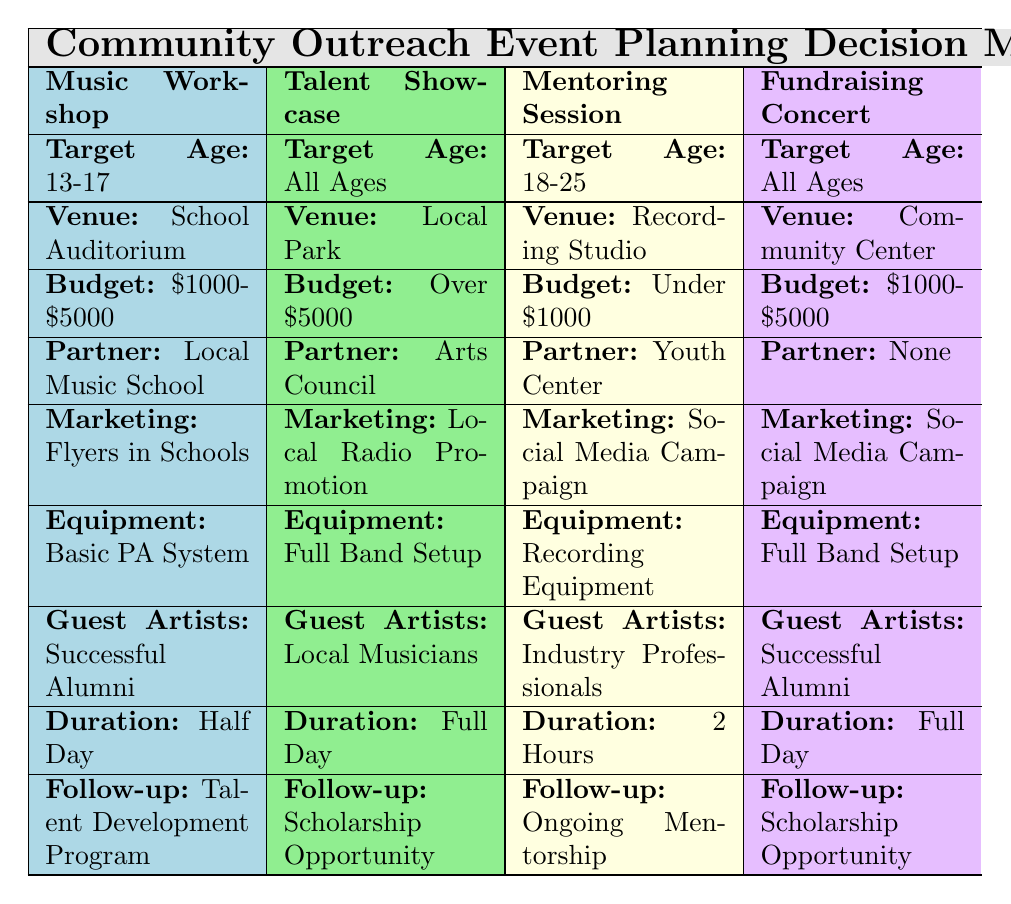What is the target age group for the Talent Showcase event? The table indicates that the target age group for the Talent Showcase event is "All Ages." This is directly referenced in the specific row dedicated to the Talent Showcase.
Answer: All Ages What budget range is associated with the Music Workshop? The Music Workshop has a budget range specified as "$1000-$5000." This information is found in the corresponding row below the Music Workshop column.
Answer: $1000-$5000 True or False: The Fundraising Concert requires a basic PA system. The table shows that the Equipment Needed for the Fundraising Concert is "Full Band Setup," which means it does not require a basic PA system. Thus, the statement is false.
Answer: False What follow-up activity is planned for the Mentoring Session? According to the table, the follow-up activity for the Mentoring Session is "Ongoing Mentorship." This is outlined in the dedicated row for the Mentoring Session.
Answer: Ongoing Mentorship Which event has the longest duration planned? The Talent Showcase and the Fundraising Concert both have a duration planned as "Full Day." Comparing all durations listed, both of these events have the longest planned duration, while others are shorter.
Answer: Full Day (Talent Showcase, Fundraising Concert) How many different guest artist options are associated with events targeted for All Ages? For the events "Talent Showcase" and "Fundraising Concert," which both target "All Ages," the guest artist options found are "Local Musicians" (Talent Showcase) and "Successful Alumni" (Fundraising Concert). Thus, there are two different options for All Ages events.
Answer: 2 What marketing strategy is used for the Music Workshop and the Fundraising Concert? Both the Music Workshop and the Fundraising Concert utilize "Social Media Campaign" as their marketing strategy, as listed in their respective rows. Thus, they share the same marketing approach.
Answer: Social Media Campaign What is the common venue for the events targeting age group 18-25? The event targeting age group 18-25 is the Mentoring Session, and it is held at the "Recording Studio," as referenced in the respective row.
Answer: Recording Studio What is the budget range for events partnered with the Arts Council? The only event associated with the Arts Council is the Talent Showcase, which has a budget listed as "Over $5000," so this is the applicable budget range for events partnered with this organization.
Answer: Over $5000 